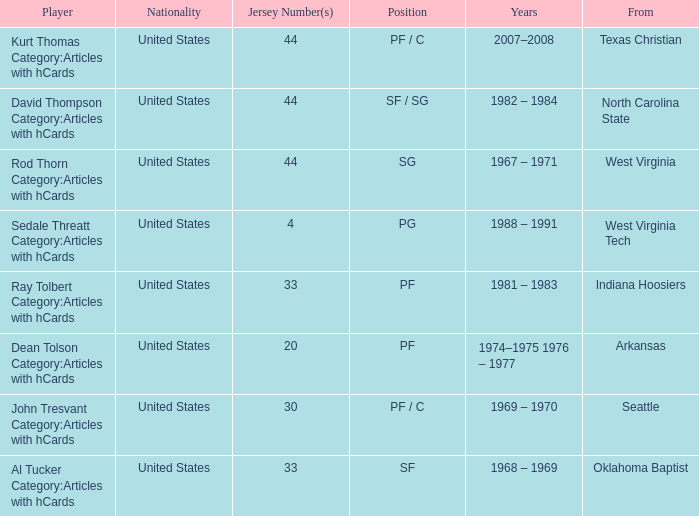In which years did the player wearing the number 33 jersey and playing as a power forward participate? 1981 – 1983. 